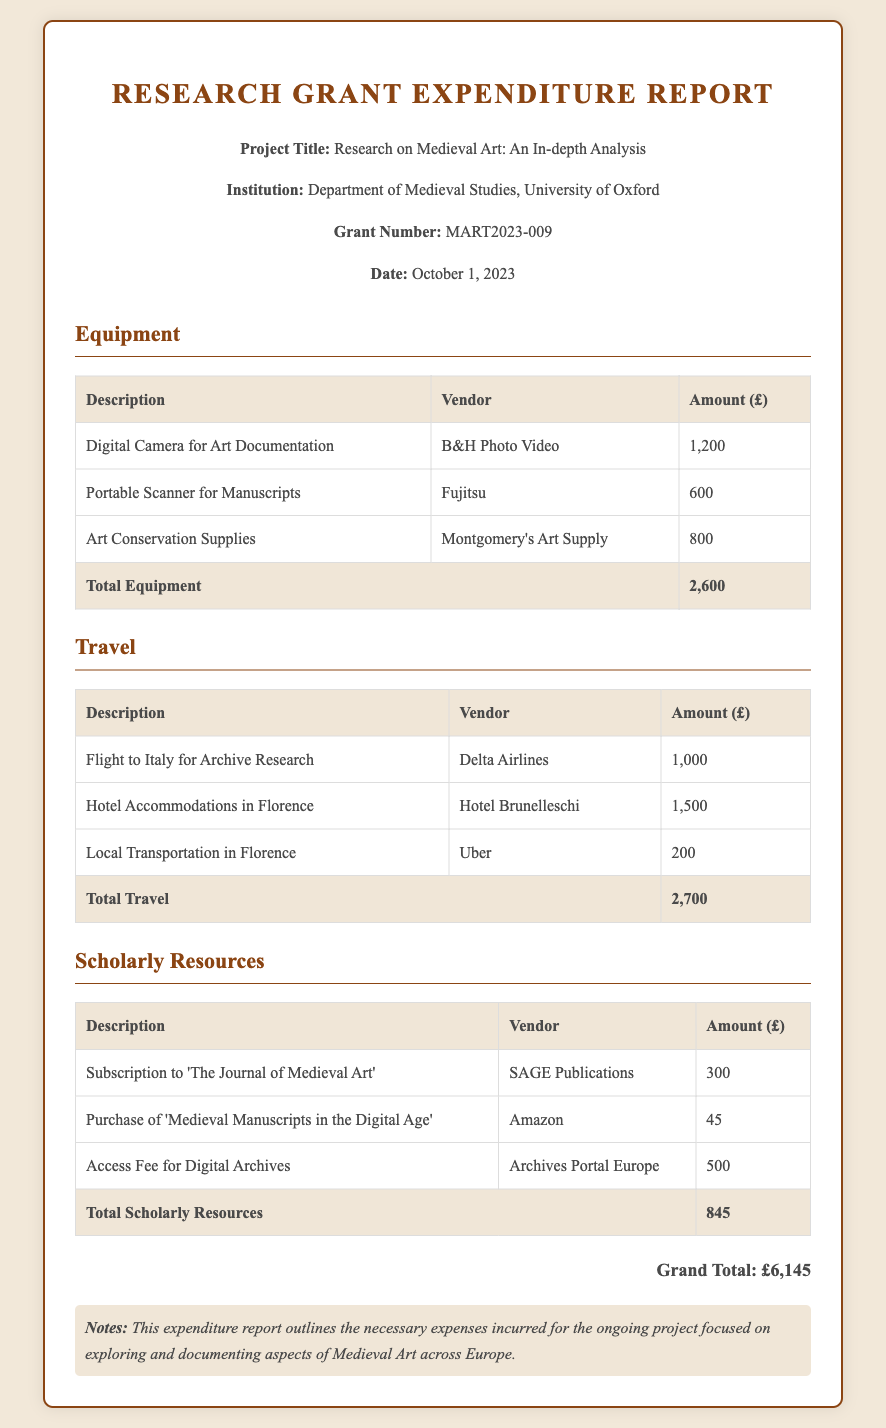what is the project title? The project title is mentioned in the header section of the document.
Answer: Research on Medieval Art: An In-depth Analysis who is the vendor for the digital camera? The vendor information can be found in the Equipment section of the document.
Answer: B&H Photo Video how much was spent on art conservation supplies? The amount spent can be found in the Equipment table under its respective row.
Answer: 800 what is the total expenditure on travel? The total for travel is aggregated from the individual travel expenses listed in the Travel section.
Answer: 2,700 who published 'The Journal of Medieval Art'? This information is listed in the Scholarly Resources section alongside each resource description.
Answer: SAGE Publications what is the grand total amount spent? The grand total is provided at the end of the expenditure report summarizing all categories.
Answer: £6,145 how many items are listed under Scholarly Resources? The number of items can be counted by examining the records in the Scholarly Resources section.
Answer: 3 which vendor provided the portable scanner? The vendor details are available in the Equipment section for each item.
Answer: Fujitsu what was the amount spent on local transportation? The local transportation cost is specified in the Travel table under its respective row.
Answer: 200 